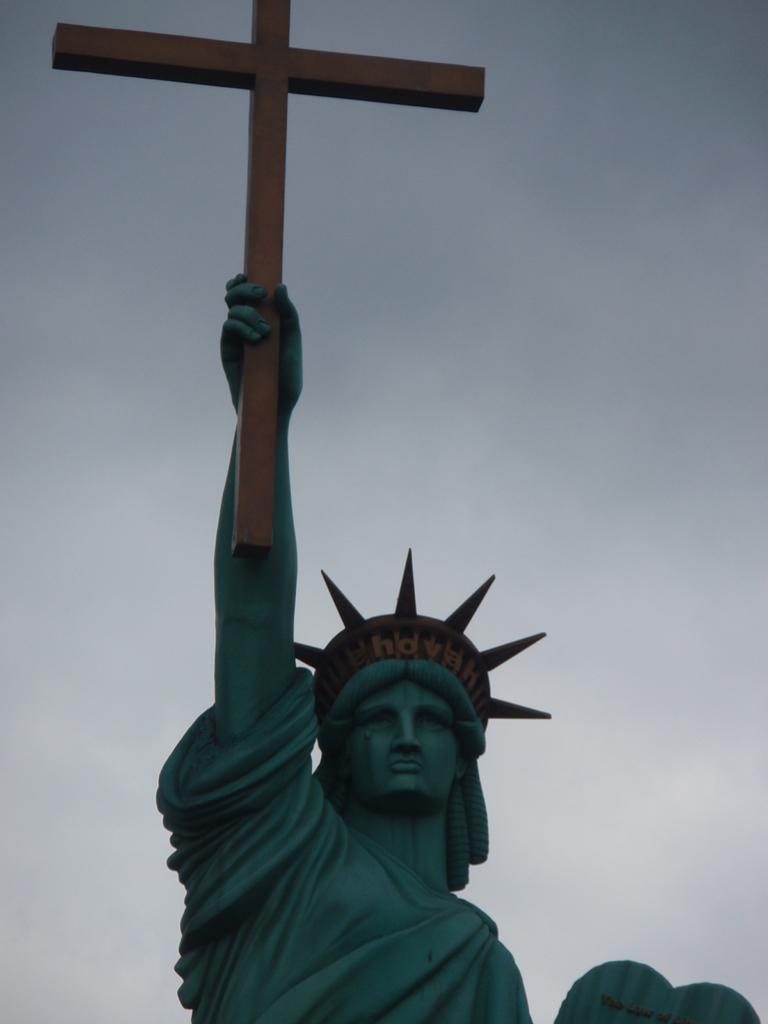Please provide a concise description of this image. In this image we can see statue which is holding holy cross in hands. 